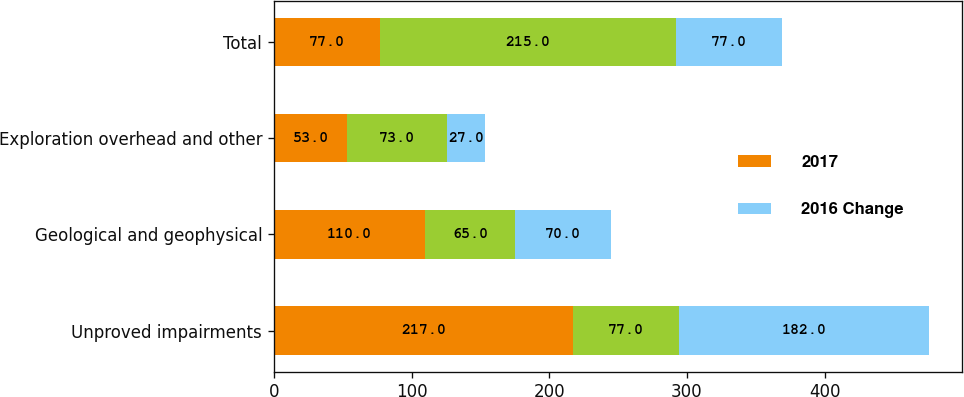<chart> <loc_0><loc_0><loc_500><loc_500><stacked_bar_chart><ecel><fcel>Unproved impairments<fcel>Geological and geophysical<fcel>Exploration overhead and other<fcel>Total<nl><fcel>2017<fcel>217<fcel>110<fcel>53<fcel>77<nl><fcel>nan<fcel>77<fcel>65<fcel>73<fcel>215<nl><fcel>2016 Change<fcel>182<fcel>70<fcel>27<fcel>77<nl></chart> 